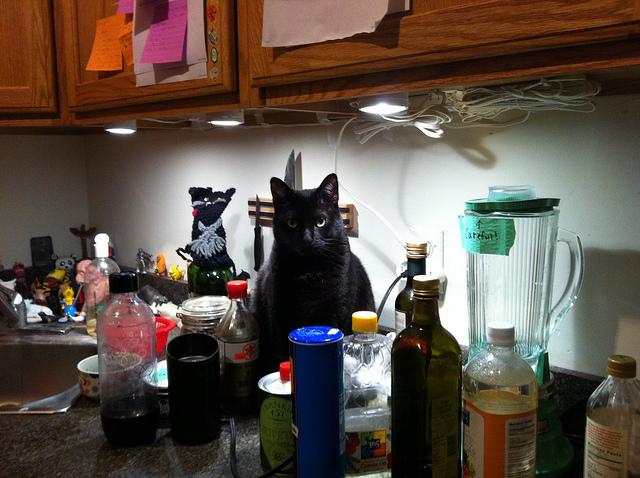How many animals are on the counter?
Write a very short answer. 1. What do all the ingredients make?
Give a very brief answer. Drink. Are there any lights on?
Give a very brief answer. Yes. 